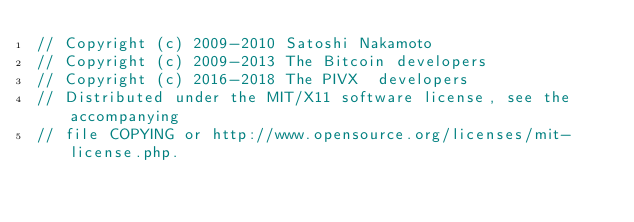<code> <loc_0><loc_0><loc_500><loc_500><_C_>// Copyright (c) 2009-2010 Satoshi Nakamoto
// Copyright (c) 2009-2013 The Bitcoin developers
// Copyright (c) 2016-2018 The PIVX  developers
// Distributed under the MIT/X11 software license, see the accompanying
// file COPYING or http://www.opensource.org/licenses/mit-license.php.
</code> 